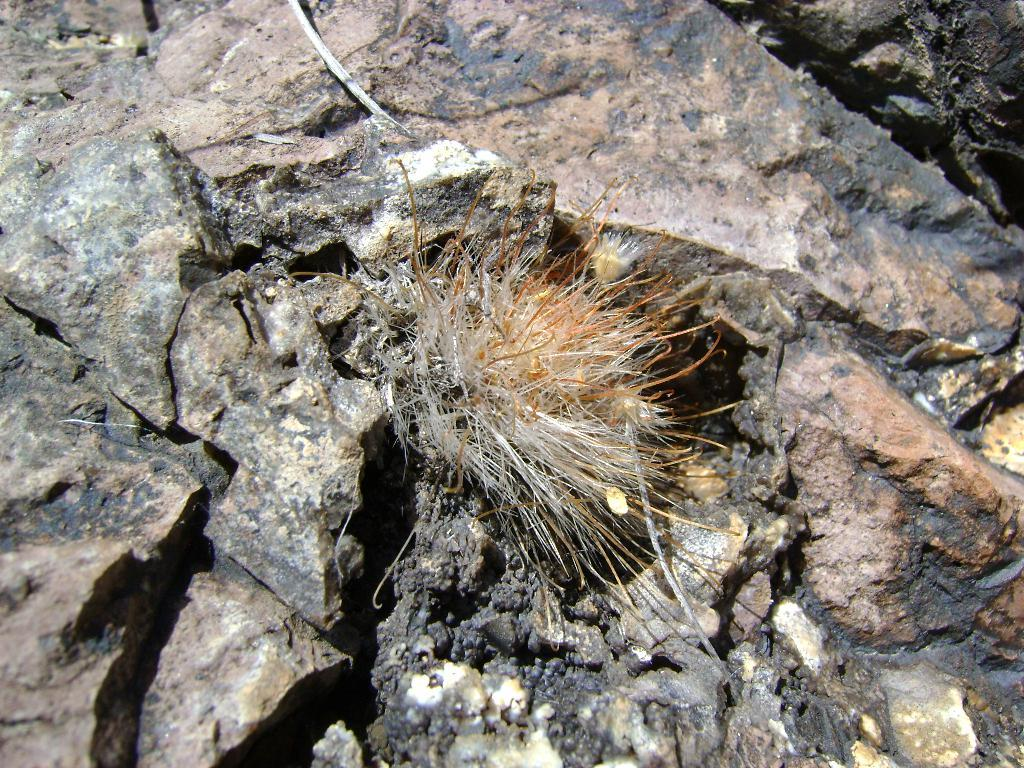What is the main subject of the image? The main subject of the image is a stone. What is placed on the stone? There is a cream and brown colored object on the stone. How many cacti can be seen growing near the stone in the image? There are no cacti visible in the image; it only features a stone with a cream and brown colored object on it. What type of celery is being used to power the trains in the image? There are no trains or celery present in the image; it only features a stone with a cream and brown colored object on it. 